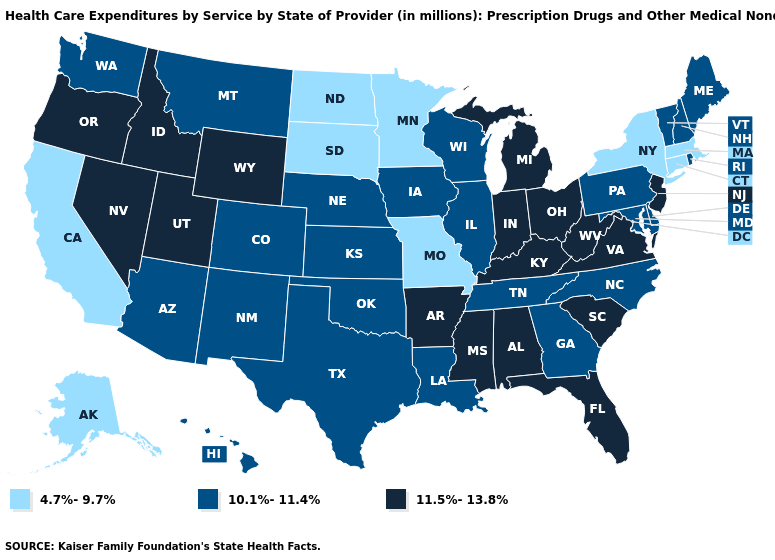What is the value of Iowa?
Be succinct. 10.1%-11.4%. Among the states that border Indiana , which have the lowest value?
Be succinct. Illinois. Among the states that border New Hampshire , which have the highest value?
Be succinct. Maine, Vermont. Name the states that have a value in the range 10.1%-11.4%?
Answer briefly. Arizona, Colorado, Delaware, Georgia, Hawaii, Illinois, Iowa, Kansas, Louisiana, Maine, Maryland, Montana, Nebraska, New Hampshire, New Mexico, North Carolina, Oklahoma, Pennsylvania, Rhode Island, Tennessee, Texas, Vermont, Washington, Wisconsin. What is the value of Maine?
Write a very short answer. 10.1%-11.4%. What is the value of Hawaii?
Write a very short answer. 10.1%-11.4%. What is the lowest value in states that border Kentucky?
Short answer required. 4.7%-9.7%. Name the states that have a value in the range 10.1%-11.4%?
Be succinct. Arizona, Colorado, Delaware, Georgia, Hawaii, Illinois, Iowa, Kansas, Louisiana, Maine, Maryland, Montana, Nebraska, New Hampshire, New Mexico, North Carolina, Oklahoma, Pennsylvania, Rhode Island, Tennessee, Texas, Vermont, Washington, Wisconsin. Name the states that have a value in the range 4.7%-9.7%?
Give a very brief answer. Alaska, California, Connecticut, Massachusetts, Minnesota, Missouri, New York, North Dakota, South Dakota. Which states have the highest value in the USA?
Give a very brief answer. Alabama, Arkansas, Florida, Idaho, Indiana, Kentucky, Michigan, Mississippi, Nevada, New Jersey, Ohio, Oregon, South Carolina, Utah, Virginia, West Virginia, Wyoming. Which states have the lowest value in the West?
Concise answer only. Alaska, California. What is the lowest value in the MidWest?
Answer briefly. 4.7%-9.7%. How many symbols are there in the legend?
Quick response, please. 3. Name the states that have a value in the range 10.1%-11.4%?
Concise answer only. Arizona, Colorado, Delaware, Georgia, Hawaii, Illinois, Iowa, Kansas, Louisiana, Maine, Maryland, Montana, Nebraska, New Hampshire, New Mexico, North Carolina, Oklahoma, Pennsylvania, Rhode Island, Tennessee, Texas, Vermont, Washington, Wisconsin. 